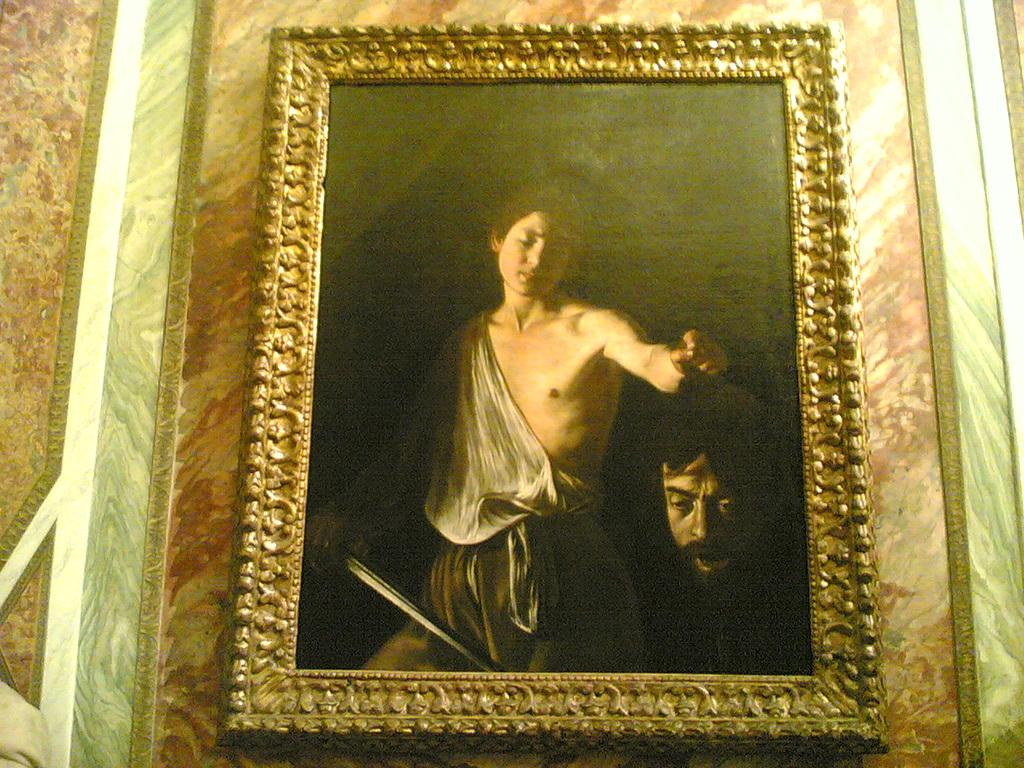What object is present in the image that typically holds a photograph or image? There is a photo frame in the image. What is depicted in the photo frame? The photo frame contains an image of a person standing and holding a sword and another person's head. Where is the photo frame located in the image? The photo frame is attached to a wall. How many snakes are slithering around the person holding the sword in the image? There are no snakes present in the image; it features a person holding a sword and another person's head. 